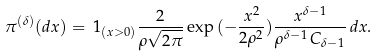Convert formula to latex. <formula><loc_0><loc_0><loc_500><loc_500>\pi ^ { ( \delta ) } ( d x ) = \, 1 _ { ( x > 0 ) } \frac { 2 } { \rho \sqrt { 2 \pi } } \exp { ( - \frac { x ^ { 2 } } { 2 \rho ^ { 2 } } ) } \frac { x ^ { \delta - 1 } } { \rho ^ { \delta - 1 } \, C _ { \delta - 1 } } \, d x .</formula> 